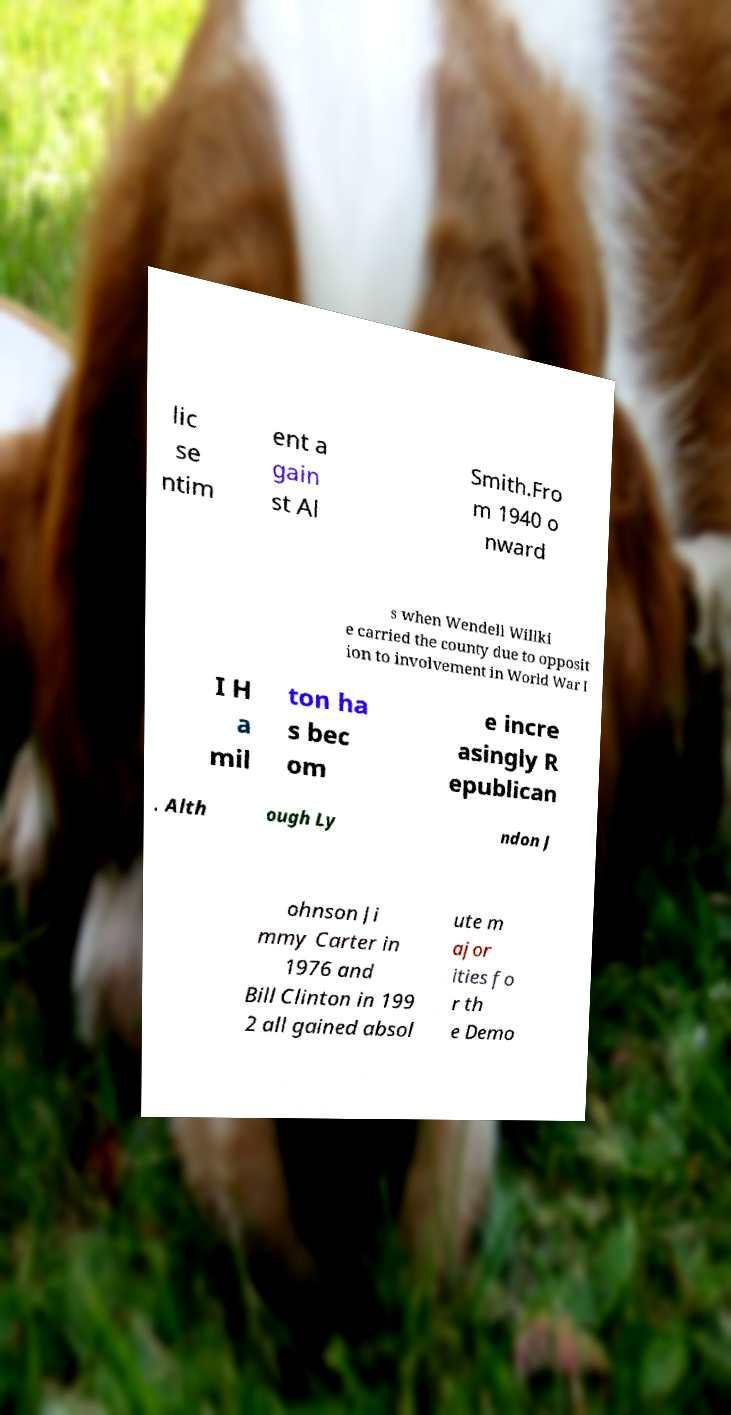Can you read and provide the text displayed in the image?This photo seems to have some interesting text. Can you extract and type it out for me? lic se ntim ent a gain st Al Smith.Fro m 1940 o nward s when Wendell Willki e carried the county due to opposit ion to involvement in World War I I H a mil ton ha s bec om e incre asingly R epublican . Alth ough Ly ndon J ohnson Ji mmy Carter in 1976 and Bill Clinton in 199 2 all gained absol ute m ajor ities fo r th e Demo 